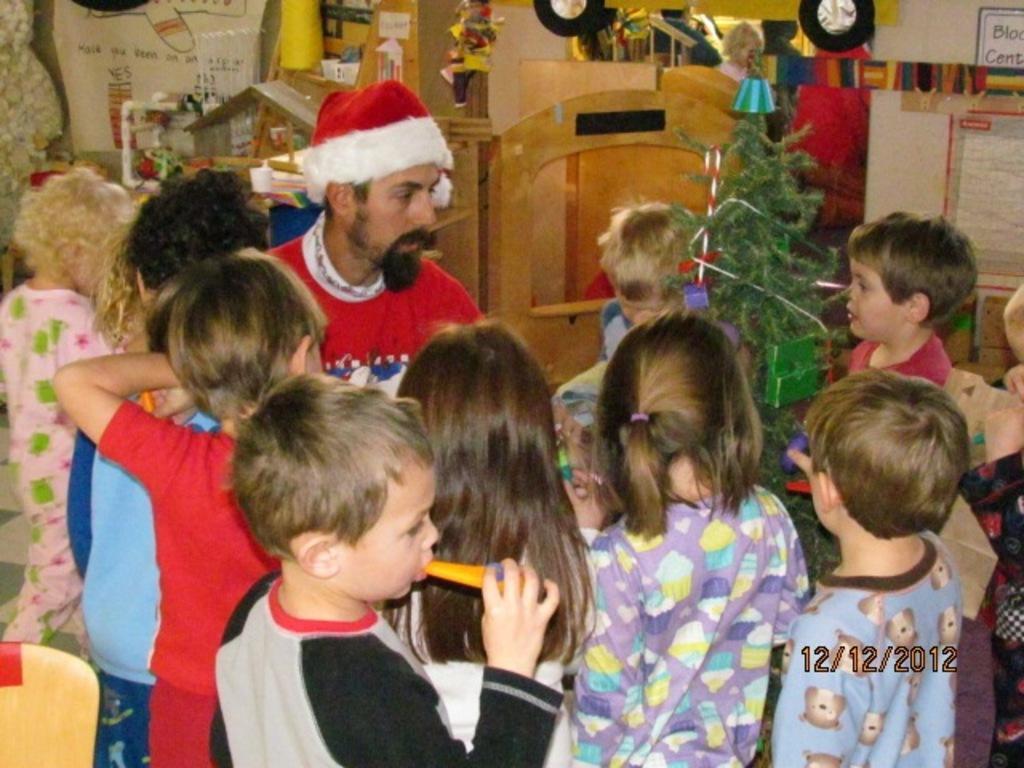Can you describe this image briefly? In the image there is a man and around him there are a group of children, behind the man there is a Christmas tree, some craft items, charts and other things. The man is wearing a Christmas cap. 